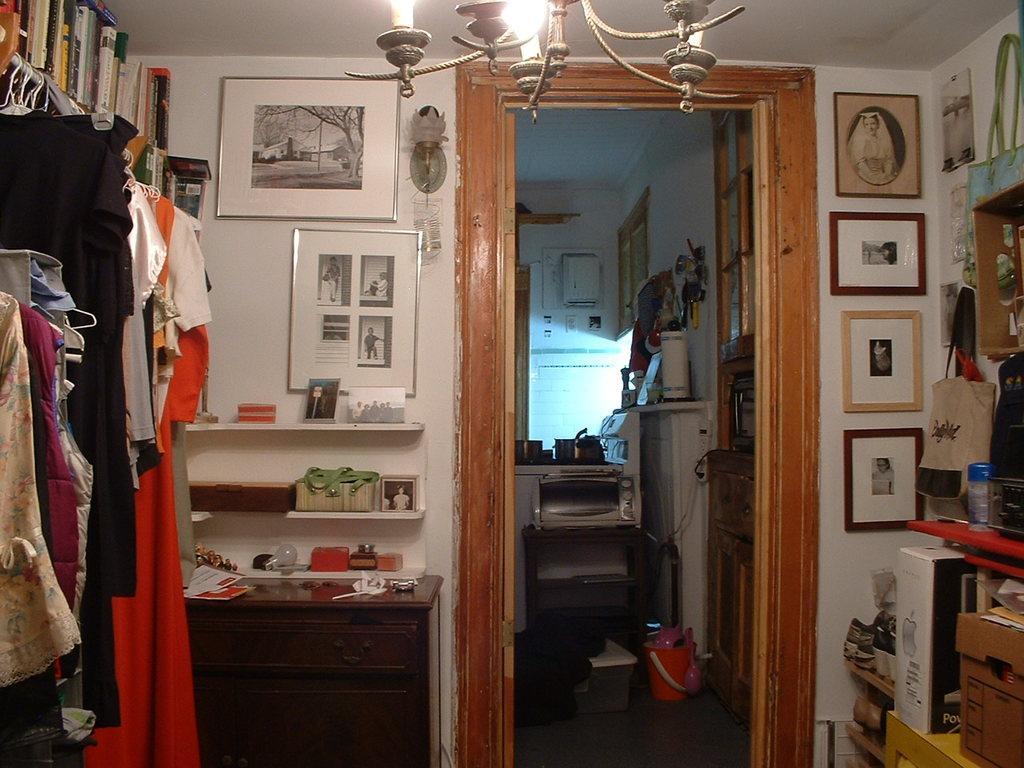Can you describe this image briefly? In this image we can see a door, a group of books, some clothes to the hangers and some photo frames on a wall. We can also see some objects placed in the shelves, some cards on a cupboard, some cardboard boxes and some objects placed in a shelf, a bag on a hanger, a lamp and a chandelier to a roof. On the backside we can see an oven on a table, some vessels on a stove and some containers placed on the floor. 